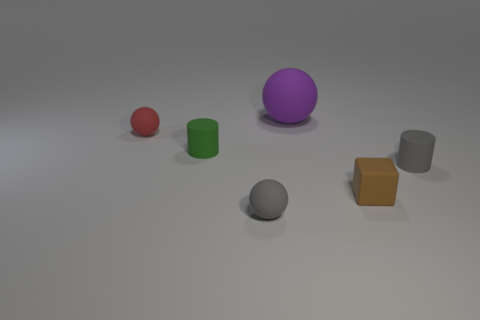Add 3 small gray cylinders. How many objects exist? 9 Subtract all blocks. How many objects are left? 5 Add 1 large purple matte things. How many large purple matte things exist? 2 Subtract 0 blue spheres. How many objects are left? 6 Subtract all purple shiny balls. Subtract all large spheres. How many objects are left? 5 Add 2 small red rubber spheres. How many small red rubber spheres are left? 3 